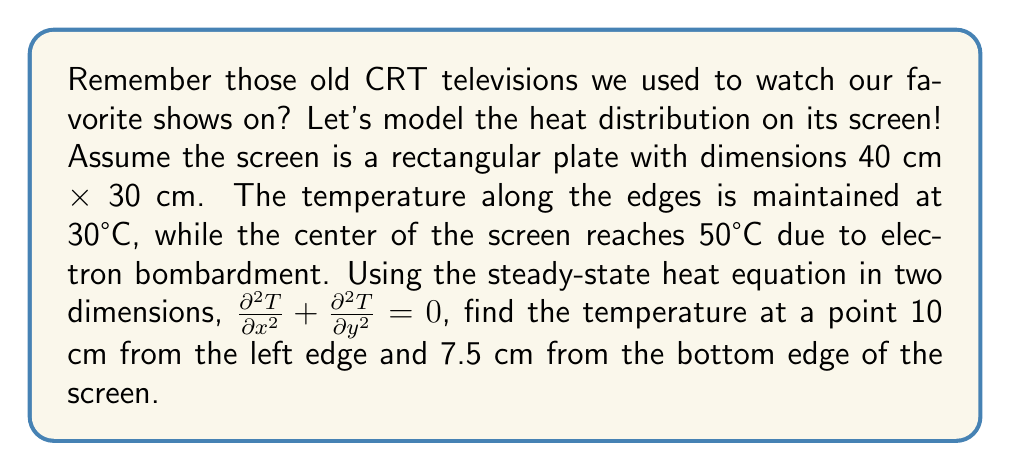Could you help me with this problem? Let's approach this step-by-step:

1) The steady-state heat equation in 2D is given by:

   $$\frac{\partial^2 T}{\partial x^2} + \frac{\partial^2 T}{\partial y^2} = 0$$

2) For a rectangular plate with these boundary conditions, the solution is:

   $$T(x,y) = T_e + \sum_{m=1}^{\infty}\sum_{n=1}^{\infty} A_{mn} \sin(\frac{m\pi x}{a}) \sin(\frac{n\pi y}{b})$$

   Where $T_e$ is the edge temperature, $a$ and $b$ are the dimensions of the plate.

3) The coefficients $A_{mn}$ are given by:

   $$A_{mn} = \frac{4}{ab} \int_0^a \int_0^b (T(x,y) - T_e) \sin(\frac{m\pi x}{a}) \sin(\frac{n\pi y}{b}) dx dy$$

4) Given the symmetry of the problem, we can approximate the temperature distribution with just the first term:

   $$T(x,y) \approx T_e + A_{11} \sin(\frac{\pi x}{a}) \sin(\frac{\pi y}{b})$$

5) The maximum temperature occurs at the center $(a/2, b/2)$, so:

   $$50 = 30 + A_{11} \sin(\frac{\pi}{2}) \sin(\frac{\pi}{2})$$
   $$A_{11} = 20$$

6) Therefore, our approximate solution is:

   $$T(x,y) \approx 30 + 20 \sin(\frac{\pi x}{40}) \sin(\frac{\pi y}{30})$$

7) At the point (10, 7.5):

   $$T(10, 7.5) \approx 30 + 20 \sin(\frac{\pi 10}{40}) \sin(\frac{\pi 7.5}{30})$$
   $$\approx 30 + 20 \sin(\frac{\pi}{4}) \sin(\frac{\pi}{4})$$
   $$\approx 30 + 20 \cdot 0.7071 \cdot 0.7071$$
   $$\approx 40°C$$
Answer: 40°C 